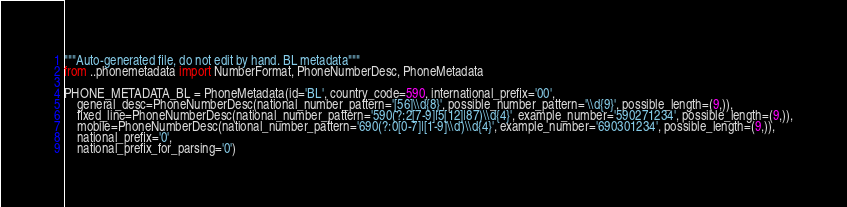<code> <loc_0><loc_0><loc_500><loc_500><_Python_>"""Auto-generated file, do not edit by hand. BL metadata"""
from ..phonemetadata import NumberFormat, PhoneNumberDesc, PhoneMetadata

PHONE_METADATA_BL = PhoneMetadata(id='BL', country_code=590, international_prefix='00',
    general_desc=PhoneNumberDesc(national_number_pattern='[56]\\d{8}', possible_number_pattern='\\d{9}', possible_length=(9,)),
    fixed_line=PhoneNumberDesc(national_number_pattern='590(?:2[7-9]|5[12]|87)\\d{4}', example_number='590271234', possible_length=(9,)),
    mobile=PhoneNumberDesc(national_number_pattern='690(?:0[0-7]|[1-9]\\d)\\d{4}', example_number='690301234', possible_length=(9,)),
    national_prefix='0',
    national_prefix_for_parsing='0')
</code> 